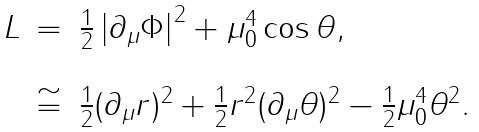Convert formula to latex. <formula><loc_0><loc_0><loc_500><loc_500>\begin{array} { l c l } L & = & \frac { 1 } { 2 } \left | \partial _ { \mu } \Phi \right | ^ { 2 } + \mu _ { 0 } ^ { 4 } \cos \theta , \\ & & \\ & \cong & \frac { 1 } { 2 } ( \partial _ { \mu } r ) ^ { 2 } + \frac { 1 } { 2 } r ^ { 2 } ( \partial _ { \mu } \theta ) ^ { 2 } - \frac { 1 } { 2 } \mu _ { 0 } ^ { 4 } \theta ^ { 2 } . \end{array}</formula> 